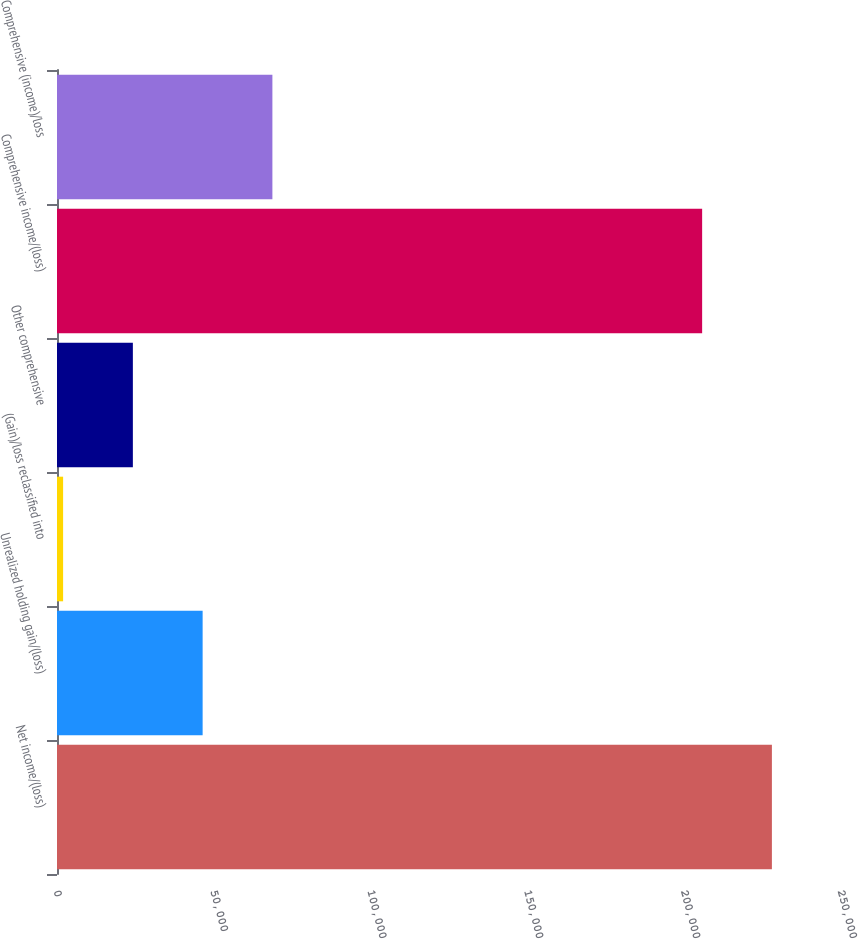Convert chart. <chart><loc_0><loc_0><loc_500><loc_500><bar_chart><fcel>Net income/(loss)<fcel>Unrealized holding gain/(loss)<fcel>(Gain)/loss reclassified into<fcel>Other comprehensive<fcel>Comprehensive income/(loss)<fcel>Comprehensive (income)/loss<nl><fcel>227965<fcel>46438.4<fcel>1948<fcel>24193.2<fcel>205720<fcel>68683.6<nl></chart> 